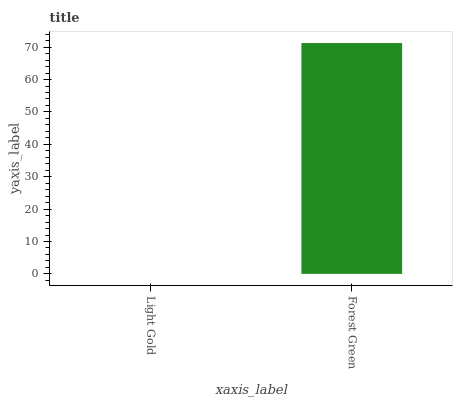Is Light Gold the minimum?
Answer yes or no. Yes. Is Forest Green the maximum?
Answer yes or no. Yes. Is Forest Green the minimum?
Answer yes or no. No. Is Forest Green greater than Light Gold?
Answer yes or no. Yes. Is Light Gold less than Forest Green?
Answer yes or no. Yes. Is Light Gold greater than Forest Green?
Answer yes or no. No. Is Forest Green less than Light Gold?
Answer yes or no. No. Is Forest Green the high median?
Answer yes or no. Yes. Is Light Gold the low median?
Answer yes or no. Yes. Is Light Gold the high median?
Answer yes or no. No. Is Forest Green the low median?
Answer yes or no. No. 